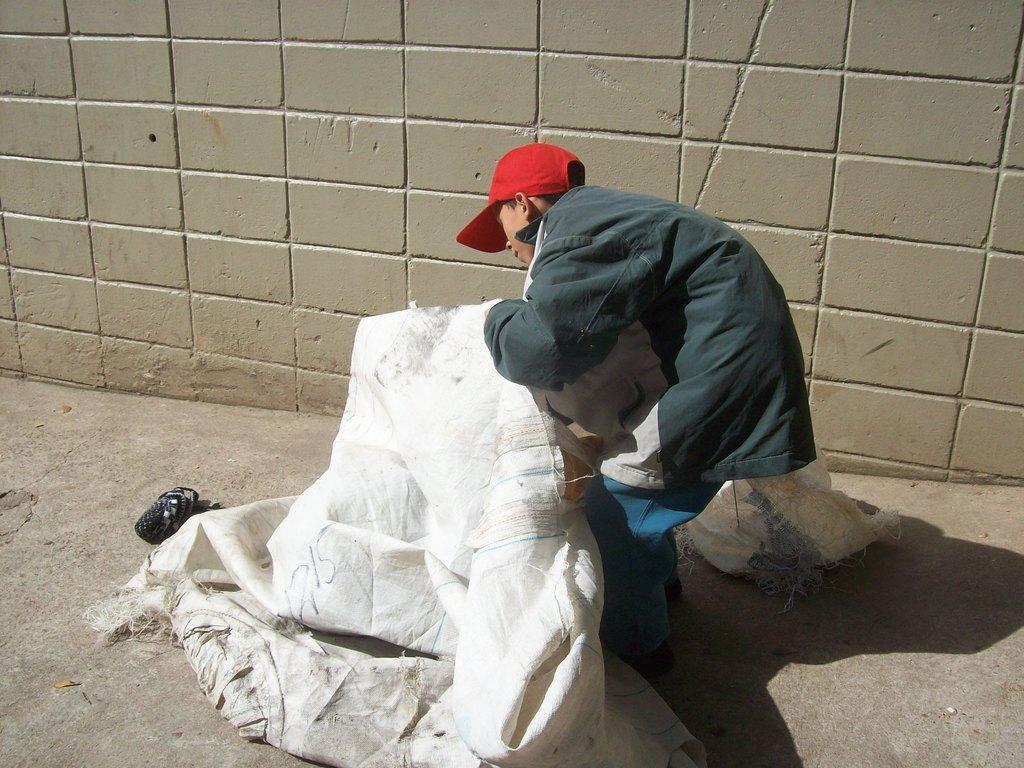How would you summarize this image in a sentence or two? In this image I can see a man holding a polypropylene cover, wearing a red color cap visible in front of the wall, there is an object visible on the left side kept on floor. 